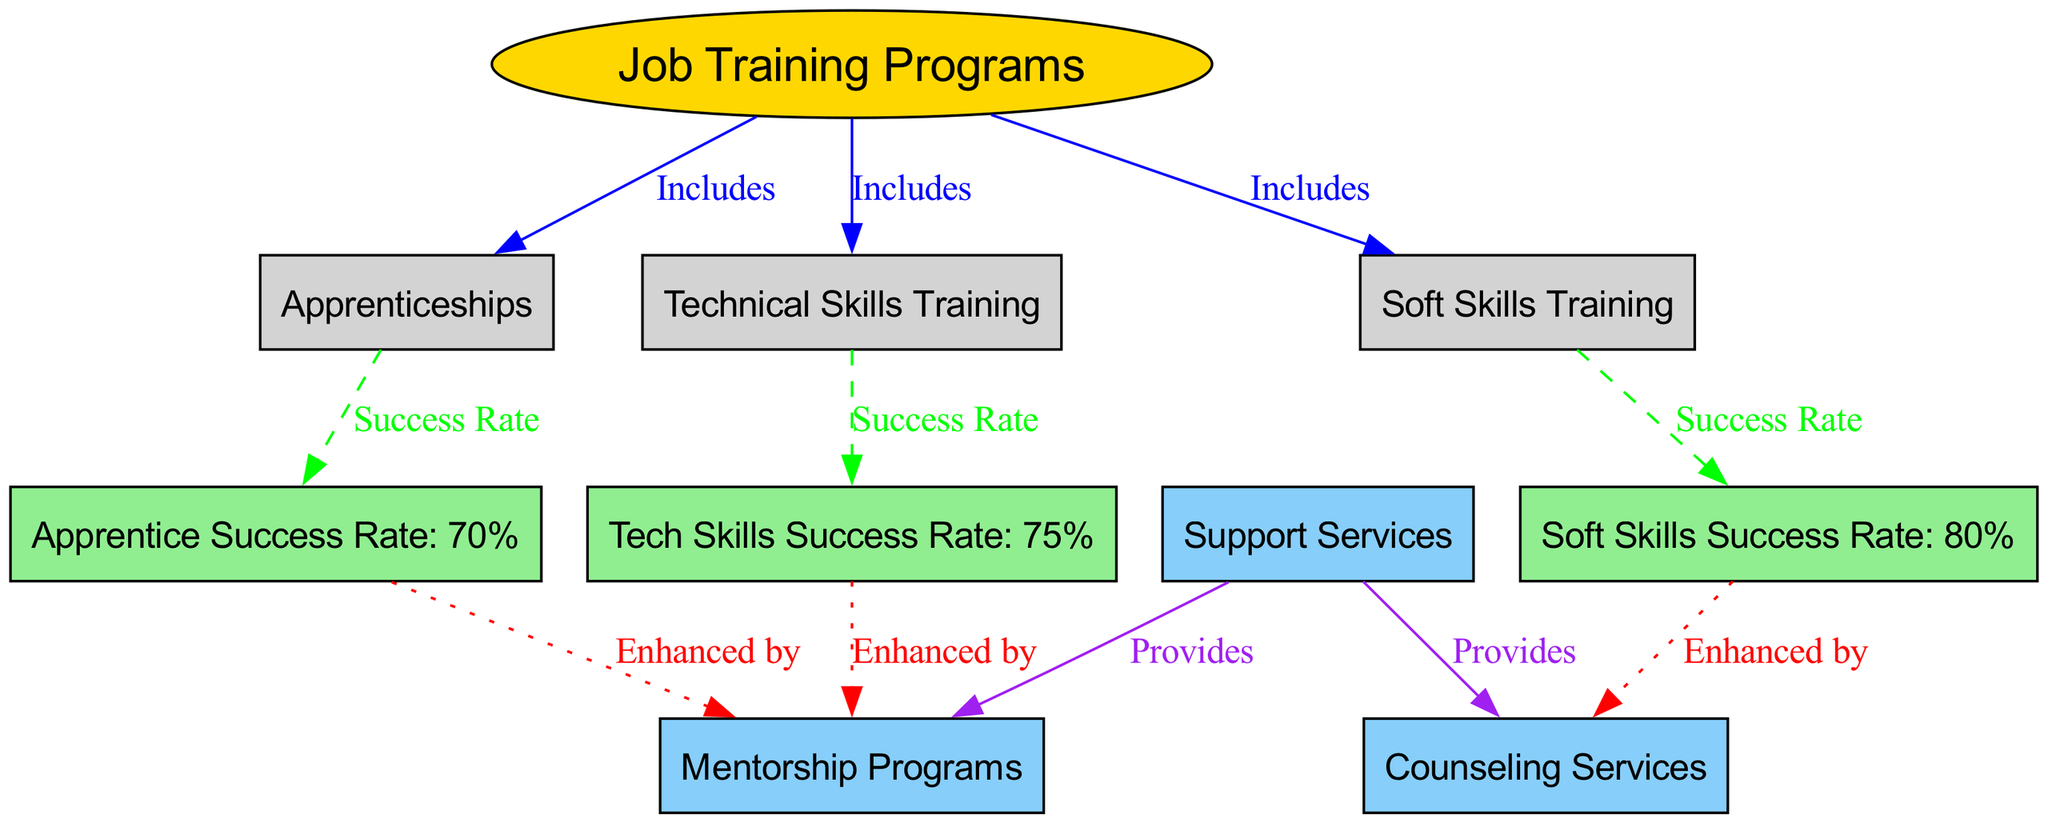What is the success rate for Technical Skills Training? The diagram indicates that the success rate for Technical Skills Training is directly connected and labeled next to it as "Tech Skills Success Rate: 75%."
Answer: 75% What type of training programs are included under Job Training Programs? The diagram shows three edges labeled "Includes" leading from Job Training Programs to Technical Skills Training, Soft Skills Training, and Apprenticeships, indicating they are part of the broader Job Training Programs.
Answer: Technical Skills Training, Soft Skills Training, Apprenticeships How many success rates are shown for the training programs? There are three nodes related to success rates: Technical Skills Success Rate, Soft Skills Success Rate, and Apprentice Success Rate, indicating that three success rates are displayed.
Answer: 3 Which support service is enhanced by the success of Soft Skills Training? The diagram links the Soft Skills Success Rate to the Counseling Services with the label "Enhanced by," indicating that Counseling enhances the success of Soft Skills Training.
Answer: Counseling Services What color represents the nodes related to success rates in this diagram? The nodes indicating success rates (Tech Skills Success Rate, Soft Skills Success Rate, and Apprentice Success Rate) are filled with light green color, which can be seen in their representation in the diagram.
Answer: Light green Which training program has the lowest success rate according to the diagram? The success rates indicated are 75% for Tech Skills, 80% for Soft Skills, and 70% for Apprenticeships. Comparing these, the Apprenticeship Success Rate of 70% is the lowest.
Answer: 70% What is the total number of nodes present in the diagram? By counting all nodes depicted in the diagram, including Job Training Programs, the three types of training, three success rates, two support services, we find a total of eleven nodes.
Answer: 11 How does Mentorship Program relate to Technical Skills Training in the diagram? The diagram shows a connection from the Tech Skills Success Rate to Mentorship Programs with the label "Enhanced by," indicating that Mentorship Programs enhance the success of Technical Skills Training.
Answer: Enhanced by Which type of training has the highest success rate? The nodes show that Soft Skills Training has a success rate of 80%, while Tech Skills Training has 75% and Apprenticeships have 70%, making Soft Skills Training the highest.
Answer: 80% 